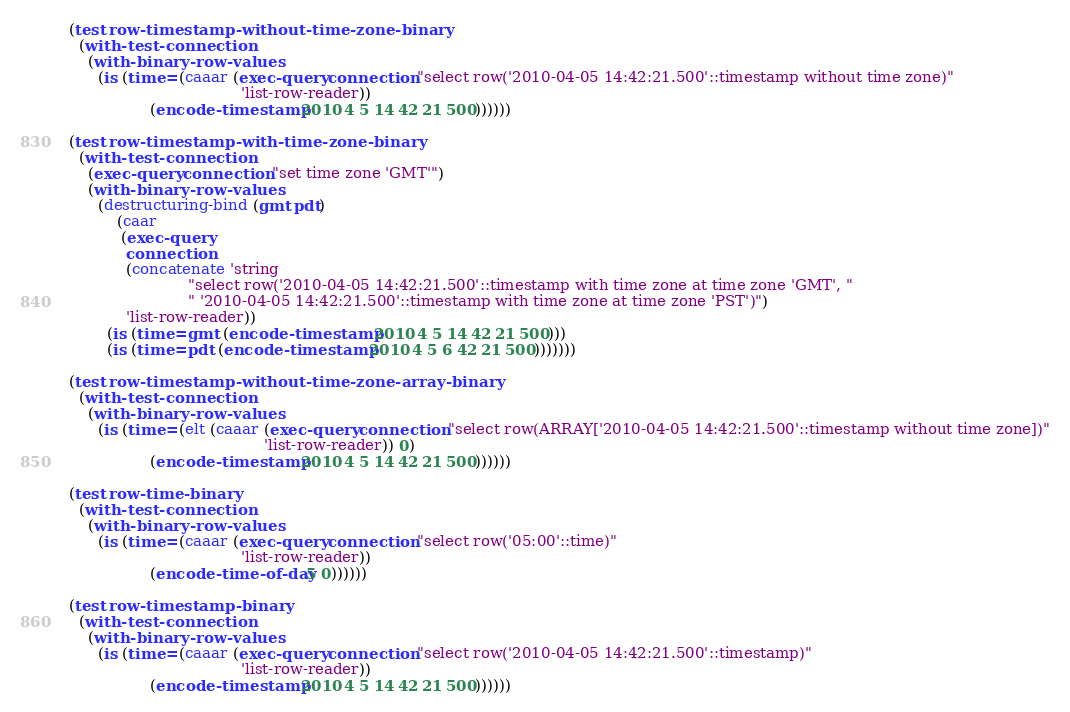Convert code to text. <code><loc_0><loc_0><loc_500><loc_500><_Lisp_>
(test row-timestamp-without-time-zone-binary
  (with-test-connection
    (with-binary-row-values
      (is (time= (caaar (exec-query connection "select row('2010-04-05 14:42:21.500'::timestamp without time zone)"
                                    'list-row-reader))
                 (encode-timestamp 2010 4 5 14 42 21 500))))))

(test row-timestamp-with-time-zone-binary
  (with-test-connection
    (exec-query connection "set time zone 'GMT'")
    (with-binary-row-values
      (destructuring-bind (gmt pdt)
          (caar
           (exec-query
            connection
            (concatenate 'string
                         "select row('2010-04-05 14:42:21.500'::timestamp with time zone at time zone 'GMT', "
                         " '2010-04-05 14:42:21.500'::timestamp with time zone at time zone 'PST')")
            'list-row-reader))
        (is (time= gmt (encode-timestamp 2010 4 5 14 42 21 500)))
        (is (time= pdt (encode-timestamp 2010 4 5 6 42 21 500)))))))

(test row-timestamp-without-time-zone-array-binary
  (with-test-connection
    (with-binary-row-values
      (is (time= (elt (caaar (exec-query connection "select row(ARRAY['2010-04-05 14:42:21.500'::timestamp without time zone])"
                                         'list-row-reader)) 0)
                 (encode-timestamp 2010 4 5 14 42 21 500))))))

(test row-time-binary
  (with-test-connection
    (with-binary-row-values
      (is (time= (caaar (exec-query connection "select row('05:00'::time)"
                                    'list-row-reader))
                 (encode-time-of-day 5 0))))))

(test row-timestamp-binary
  (with-test-connection
    (with-binary-row-values
      (is (time= (caaar (exec-query connection "select row('2010-04-05 14:42:21.500'::timestamp)"
                                    'list-row-reader))
                 (encode-timestamp 2010 4 5 14 42 21 500))))))

</code> 